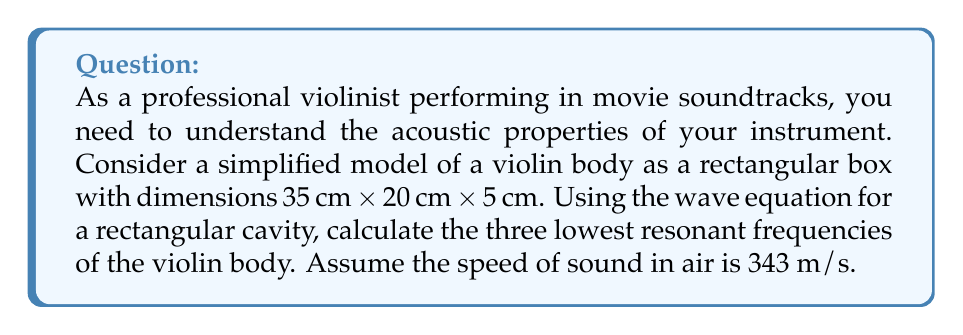Provide a solution to this math problem. To solve this problem, we'll use the wave equation for a rectangular cavity:

$$f_{n,m,l} = \frac{c}{2} \sqrt{\left(\frac{n}{L_x}\right)^2 + \left(\frac{m}{L_y}\right)^2 + \left(\frac{l}{L_z}\right)^2}$$

Where:
- $f_{n,m,l}$ is the resonant frequency
- $c$ is the speed of sound in air (343 m/s)
- $L_x$, $L_y$, and $L_z$ are the dimensions of the cavity
- $n$, $m$, and $l$ are non-negative integers representing the mode numbers

Step 1: Convert dimensions to meters
$L_x = 0.35$ m, $L_y = 0.20$ m, $L_z = 0.05$ m

Step 2: Calculate the three lowest frequencies
The lowest frequencies correspond to the smallest values of $n$, $m$, and $l$. We'll calculate:

1. $f_{1,0,0} = \frac{343}{2} \sqrt{\left(\frac{1}{0.35}\right)^2 + 0 + 0} = 490$ Hz

2. $f_{0,1,0} = \frac{343}{2} \sqrt{0 + \left(\frac{1}{0.20}\right)^2 + 0} = 857.5$ Hz

3. $f_{0,0,1} = \frac{343}{2} \sqrt{0 + 0 + \left(\frac{1}{0.05}\right)^2} = 3430$ Hz

These are the three lowest resonant frequencies of the simplified violin body model.
Answer: 490 Hz, 857.5 Hz, 3430 Hz 